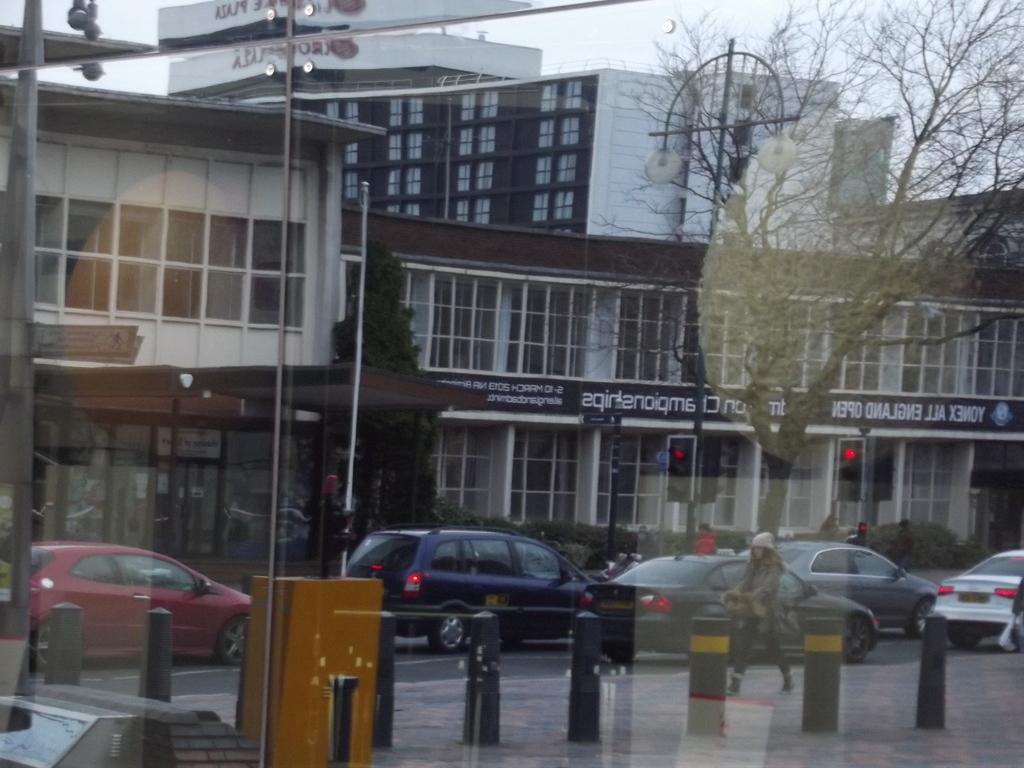What object can be seen in the image that is typically used for holding liquids? There is a glass in the image that is typically used for holding liquids. What is the person in the image doing? A person is walking on the road in the image. What else can be seen in the image besides the person walking? There are vehicles, buildings, trees, and poles in the background of the image. What type of cake is being served at the religious ceremony in the image? There is no cake or religious ceremony present in the image. 